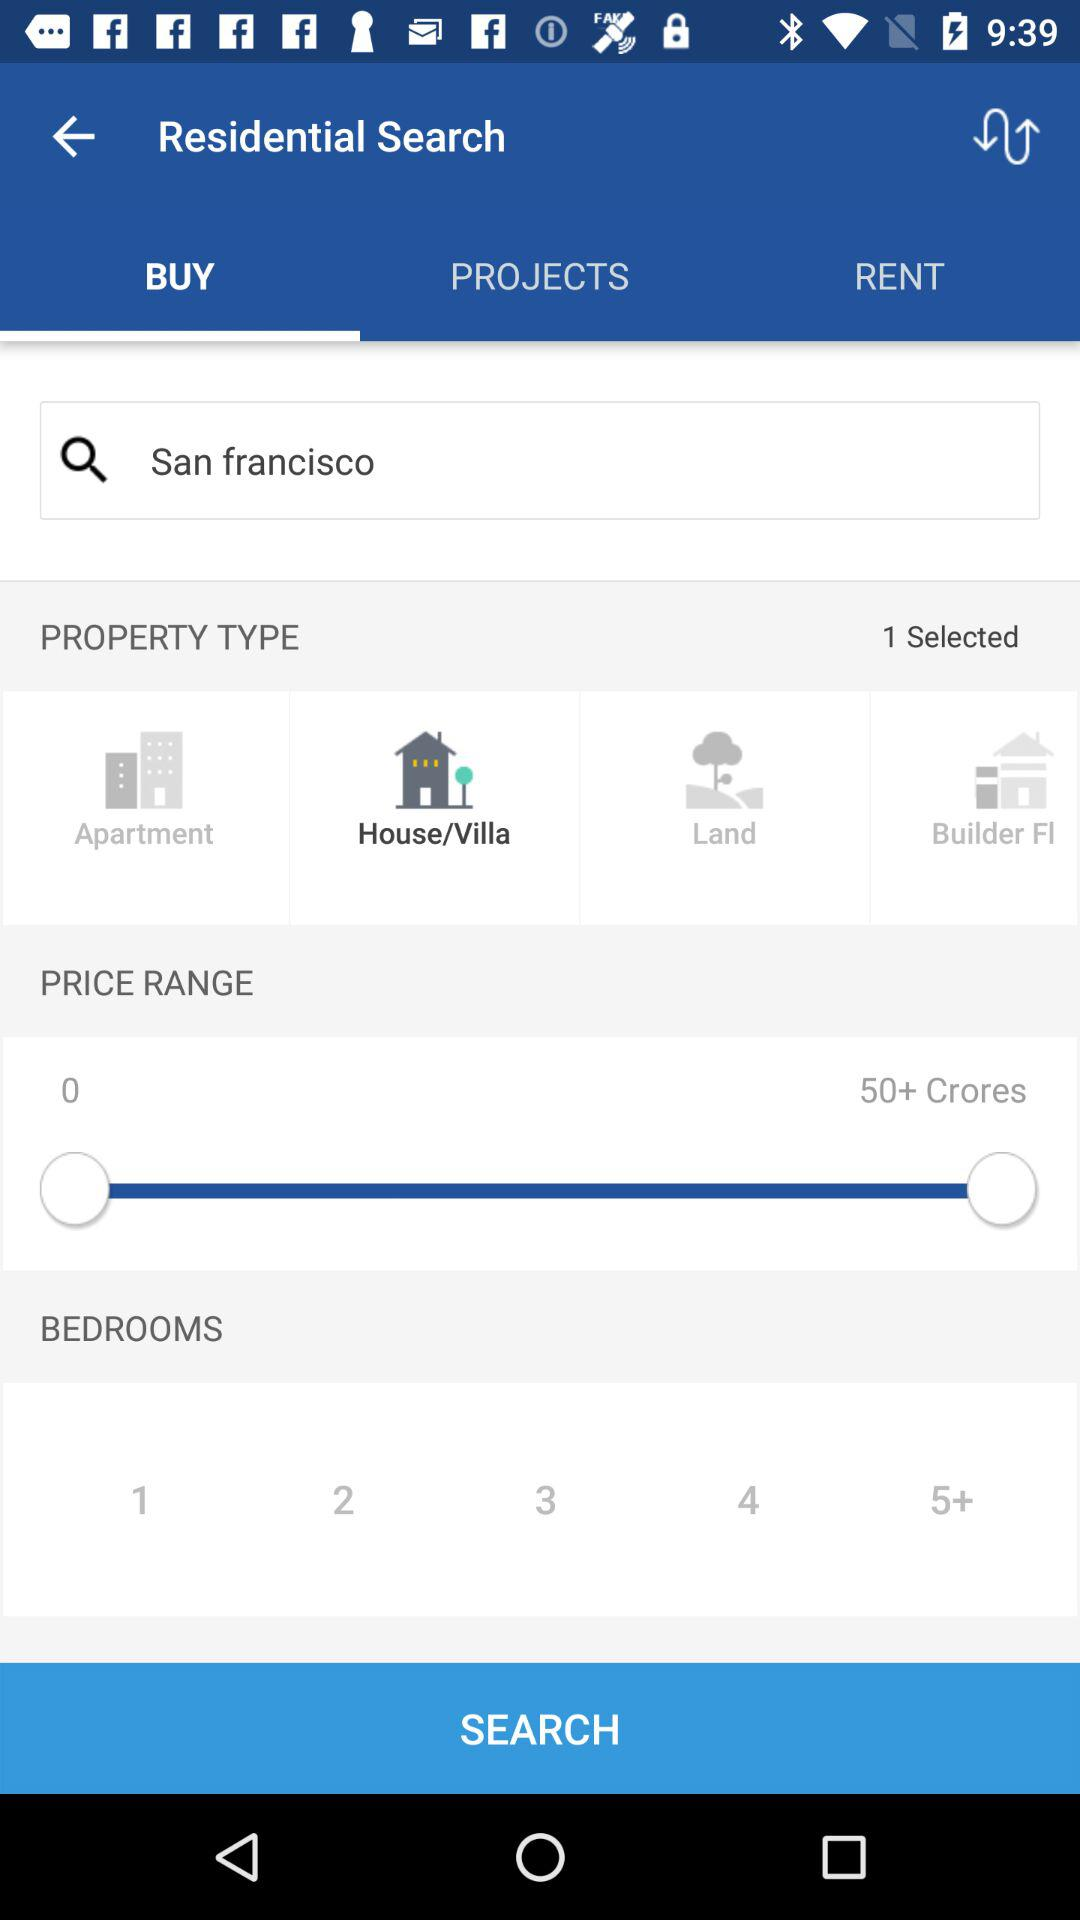What type of property is selected? The selected property type is "House/Villa". 